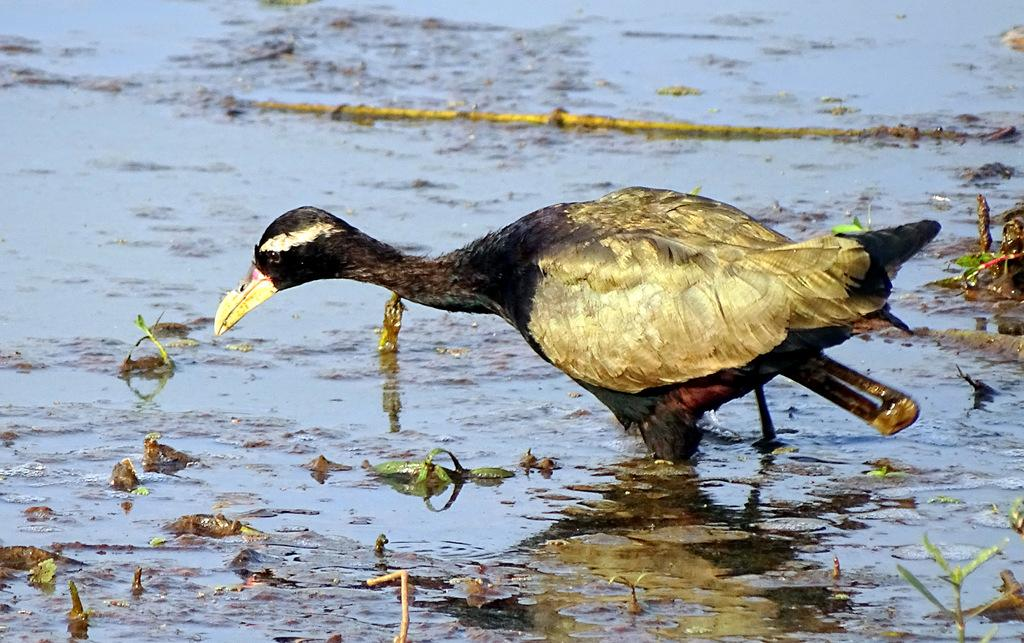What is the main subject in the middle of the image? There is a bird in the middle of the image. Where is the bird located? The bird is on the water. What can be seen on the right side of the image? There is grass on the right side of the image. What is visible in the background of the image? There is water and stocks visible in the background of the image. What type of waste can be seen in the image? There is no waste present in the image. How many horses are visible in the image? There are no horses present in the image. 